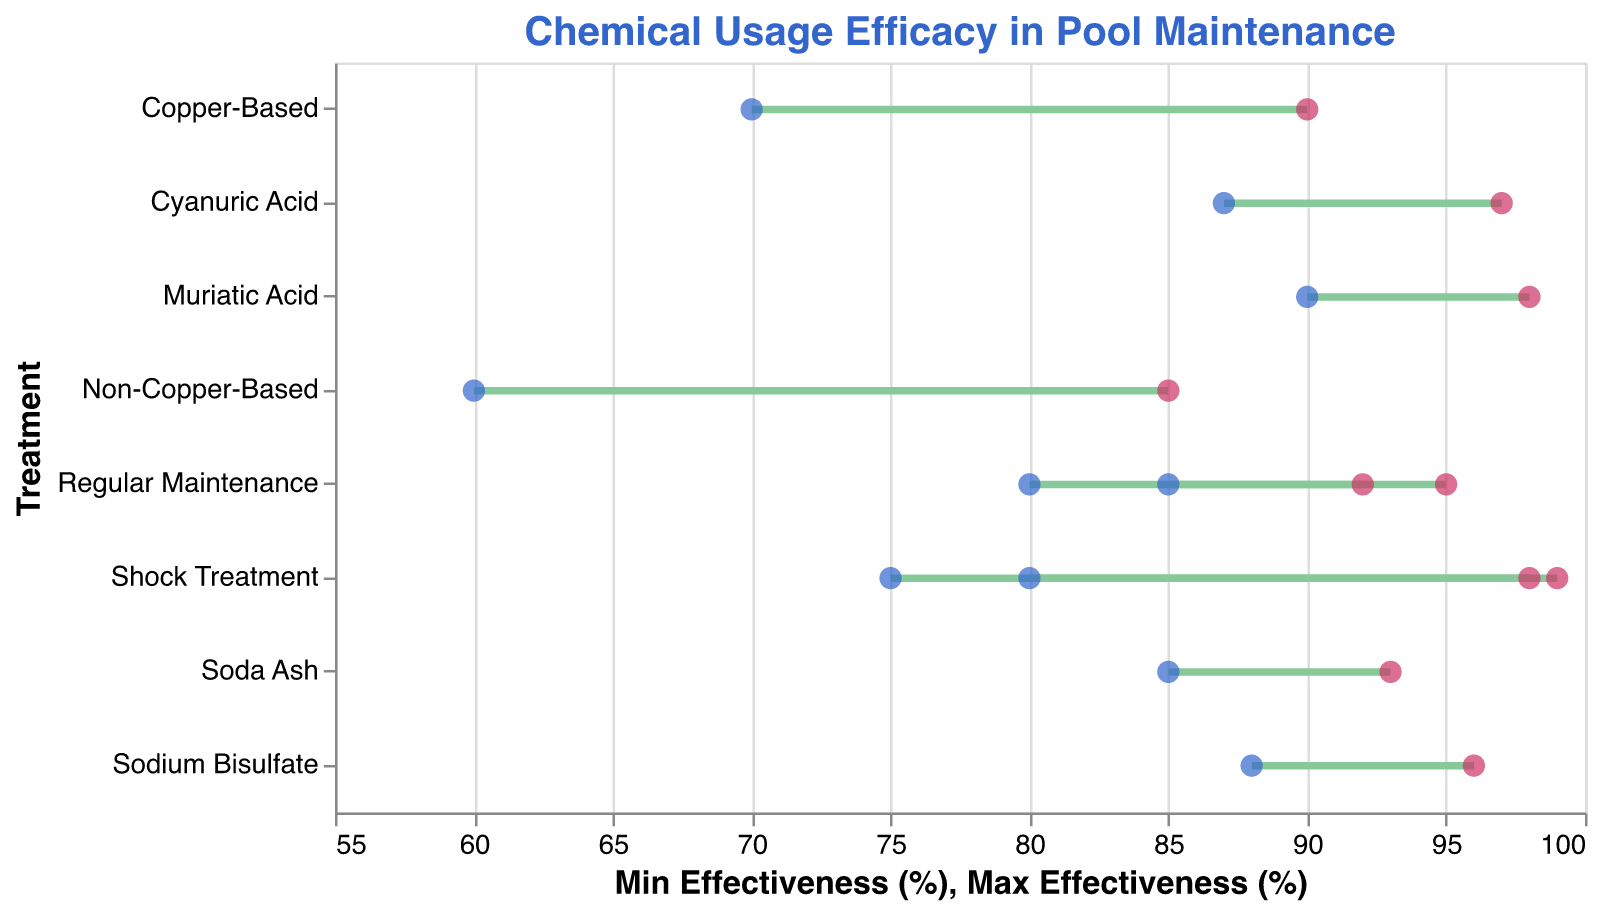What is the title of the figure? The title is positioned at the top of the figure and is prominently displayed to provide context.
Answer: Chemical Usage Efficacy in Pool Maintenance What is the treatment with the highest minimum effectiveness? Looking at the leftmost points for each treatment, the highest minimum effectiveness value belongs to the treatment positioned furthest to the right.
Answer: Muriatic Acid (pH Reducer) Which treatment has the widest range of effectiveness? The widest range can be determined by finding the treatment with the largest gap between the minimum and maximum effectiveness points (left and right points).
Answer: Shock Treatment (Chlorine) What is the effectiveness range for Sodium Bisulfate (pH Reducer)? By locating the treatment Sodium Bisulfate on the y-axis, you can see the minimum and maximum values on the x-axis next to it.
Answer: 88% - 96% How does the effectiveness range of Copper-Based Algaecide compare to Non-Copper-Based Algaecide? Compare the range of both Copper-Based and Non-Copper-Based Algaecides by looking at their end points on the x-axis.
Answer: Copper-Based (70% - 90%) has a higher range than Non-Copper-Based (60% - 85%) Which chemical type shows the most effective shock treatment? Compare the maximum effectiveness of shock treatments for different chemical types by looking at the rightmost ends of the ranges associated with "Shock Treatment."
Answer: Chlorine (99%) What is the median maximum effectiveness across all treatments? Organize the maximum effectiveness values, then find the middle value. The maximum effectiveness values are: 95, 99, 92, 98, 90, 85, 96, 98, 93, 97. The median is the average of the 5th and 6th values. (90 + 95) / 2 = 92.5
Answer: 92.5% Which treatment for pH reduction has a higher minimum effectiveness? Compare the minimum effectiveness values for "Sodium Bisulfate" and "Muriatic Acid" on the x-axis.
Answer: Muriatic Acid (90%) What is the average maximum effectiveness of all Chlorine treatments? Sum the maximum effectiveness values for Chlorine treatments and divide by the number of Chlorine treatments. (95 + 99) / 2 = 97
Answer: 97% Is the maximum effectiveness of Cyanuric Acid (Stabilizer) higher than that of Soda Ash (pH Increaser)? Compare maximum effectiveness values by observing the rightmost points on the x-axis for each treatment.
Answer: Yes, Cyanuric Acid 97% is higher than Soda Ash 93% 